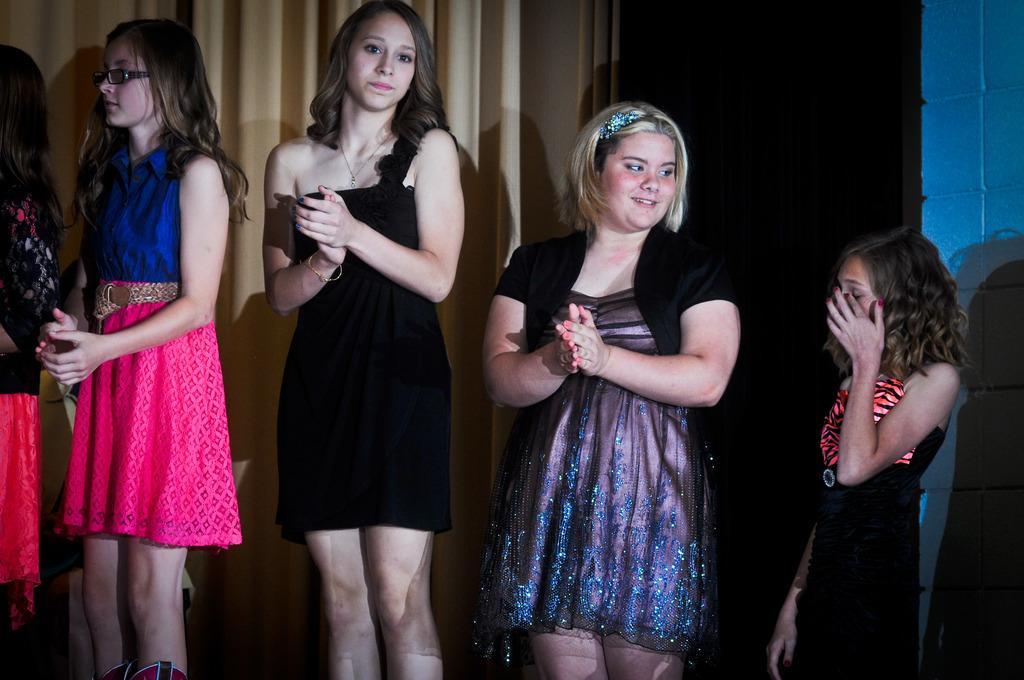How would you summarize this image in a sentence or two? In this image in the foreground there are a group of girls who are standing and clapping, in the background there is a curtain and wall and a door. 